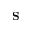<formula> <loc_0><loc_0><loc_500><loc_500>S</formula> 